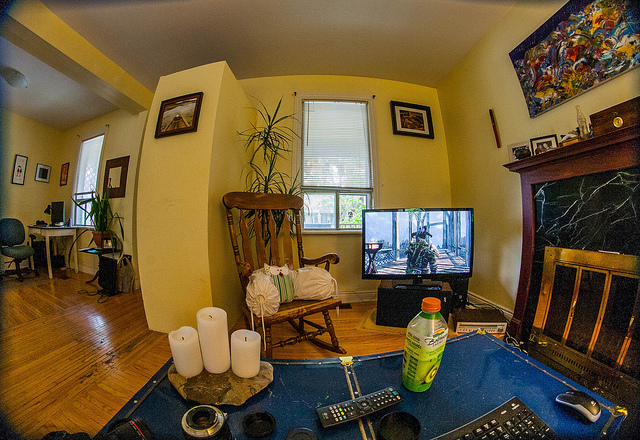<image>What pattern is on the tablecloth? There is no pattern on the tablecloth. It might be solid or plain. What pattern is on the tablecloth? It is ambiguous what pattern is on the tablecloth. It can be seen plain, blue, denim or solid. 